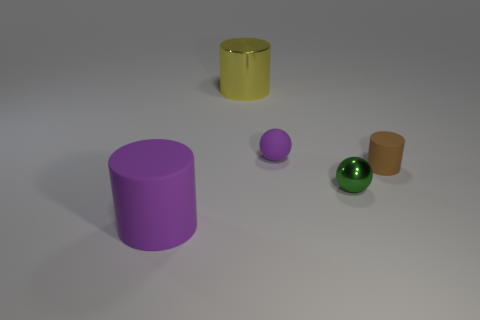Add 4 big purple objects. How many objects exist? 9 Subtract all spheres. How many objects are left? 3 Subtract all small purple matte blocks. Subtract all big purple rubber things. How many objects are left? 4 Add 3 large purple matte cylinders. How many large purple matte cylinders are left? 4 Add 5 tiny gray things. How many tiny gray things exist? 5 Subtract 0 green cylinders. How many objects are left? 5 